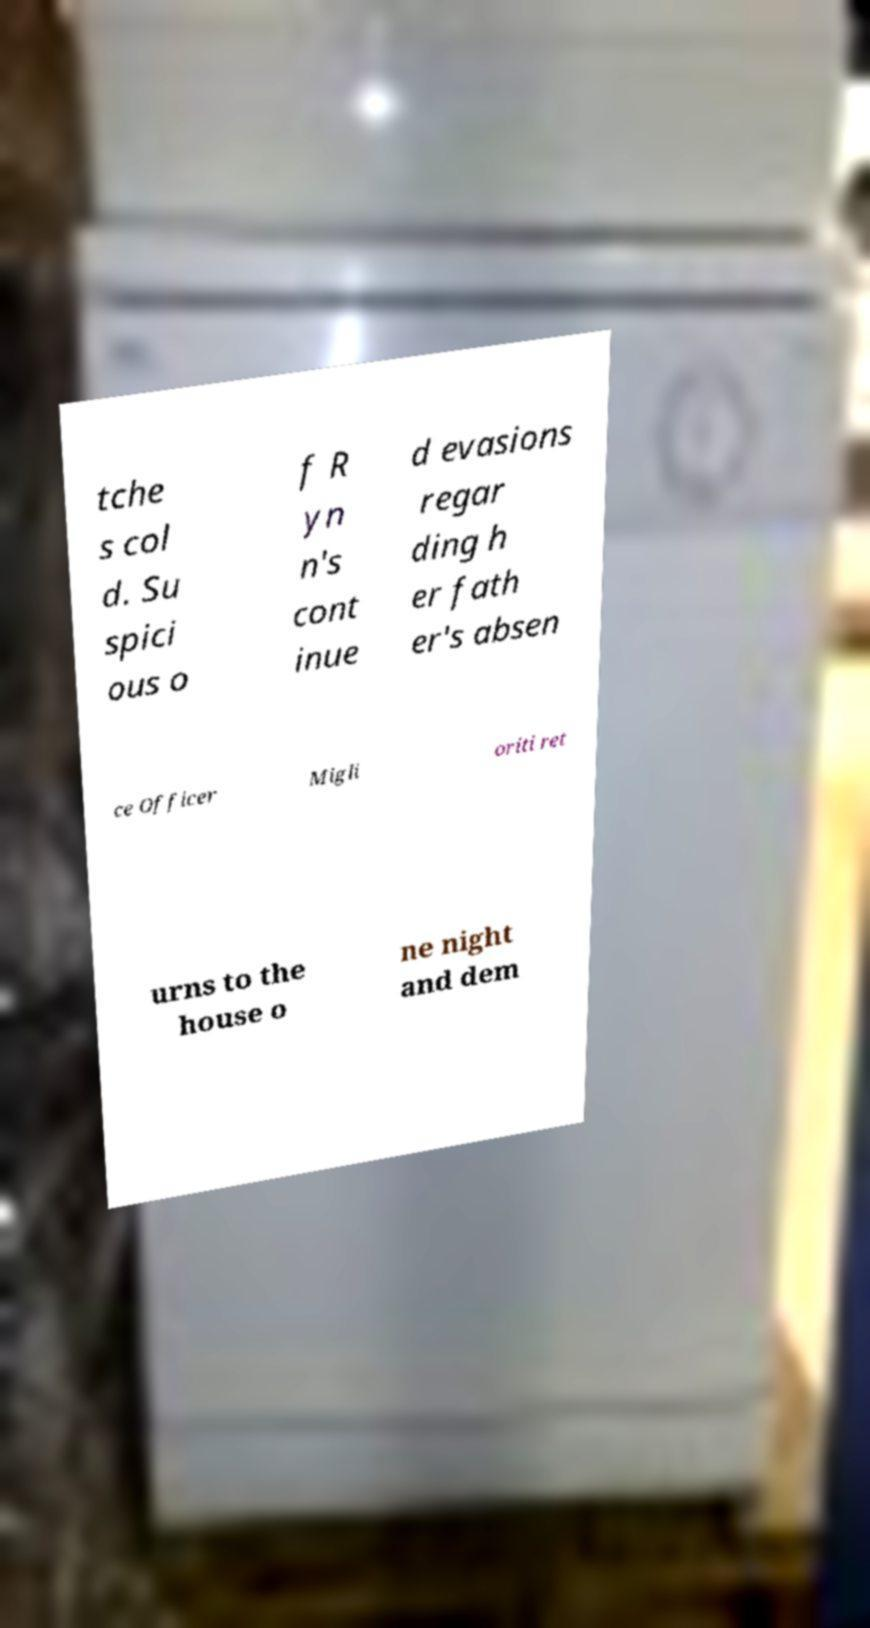Can you accurately transcribe the text from the provided image for me? tche s col d. Su spici ous o f R yn n's cont inue d evasions regar ding h er fath er's absen ce Officer Migli oriti ret urns to the house o ne night and dem 